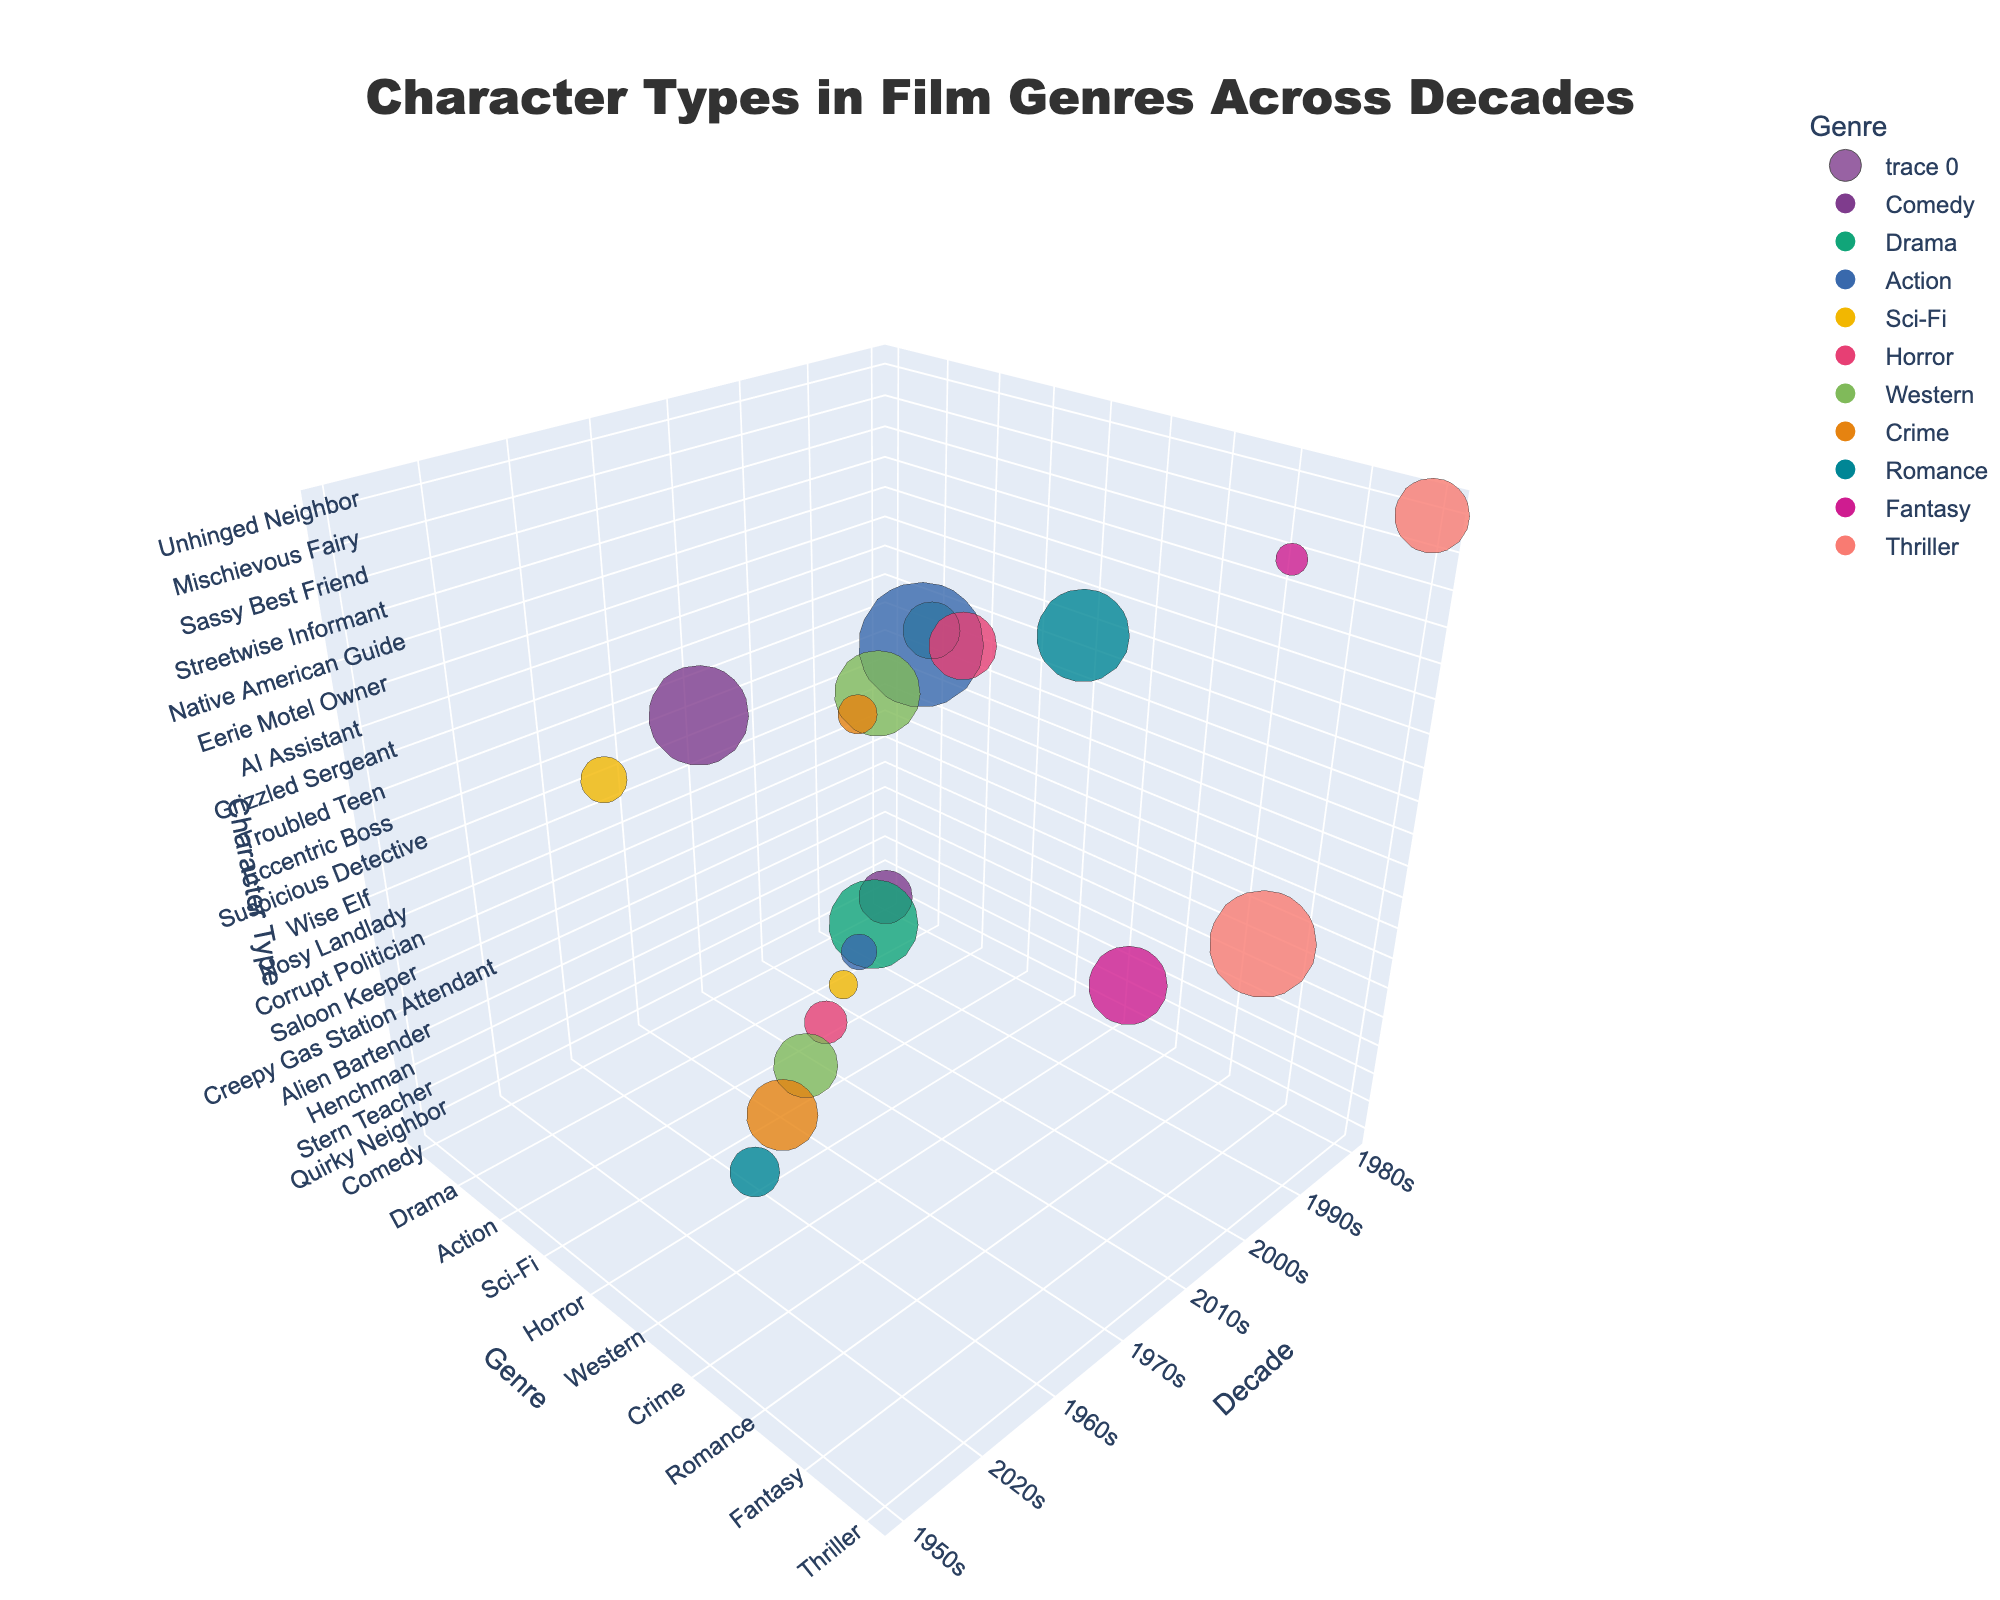What is the title of the figure? The title of the figure is typically shown at the top, usually in a larger and bolder font, to describe the content of the chart succinctly. In this case, it reads "Character Types in Film Genres Across Decades".
Answer: Character Types in Film Genres Across Decades Which genre has the largest screen time bubble in the 2020s? First, focus on the bubbles within the 2020s decade. Then, identify the largest bubble by comparing their sizes visually. The largest bubble indicates the highest screen time value. In the 2020s, the largest bubble belongs to the genre "Crime" for the character type "Corrupt Politician".
Answer: Crime How many character types are displayed for the 2010s decade? Look at the decade axis and count the number of bubbles that are positioned at the 2010s mark. Each bubble represents a unique character type within the decade. From the data, there are four character types for the 2010s.
Answer: Four What is the character type with the smallest screen time in the 2000s? Within the 2000s decade, identify the bubble with the smallest size, as the size of the bubble represents the screen time. Compare the bubble sizes for that time period to find the smallest one. The smallest bubble in the 2000s represents the character type "Henchman" from the "Action" genre.
Answer: Henchman Which genre has character types appearing in the most decades? Examine the chart to see which genre has bubbles spread across the most decades. Count the number of different decade marks for each genre. "Drama" appears in three decades (1980s, 1990s, and 2010s).
Answer: Drama Which character type in the 1980s has a screen time greater than 20 minutes? Within the 1980s decade, identify the bubble(s) representing a screen time size greater than those of 20 minutes. Use bubble size to compare and find the character type. The "Unhinged Neighbor" from the thriller genre has a screen time of 21 minutes in the 1980s.
Answer: Unhinged Neighbor Is there any genre that has character types with varying screen times observed across consecutive decades? Look for genres that have bubbles across back-to-back decades and compare their screen sizes to see if they vary. "Drama" has different screen times across the 1980s (Troubled Teen: 16 minutes) and 1990s (Stern Teacher: 25 minutes).
Answer: Yes What is the range of screen times for fictional character types in the 2010s? Identify and list the screen times for the character types in the 2010s. Calculate the difference between the maximum and minimum screen times. In the 2010s, screen times range from 8 (Alien Bartender) to 26 (Sassy Best Friend), making the range 26 - 8 = 18 minutes.
Answer: 18 minutes Which decade featured the most unique character types? Count the number of bubbles in each decade to determine which has the most unique entries. The 2010s have the most unique character types with a total of four: Alien Bartender, Wise Elf, Eccentric Boss, and Sassy Best Friend.
Answer: 2010s 